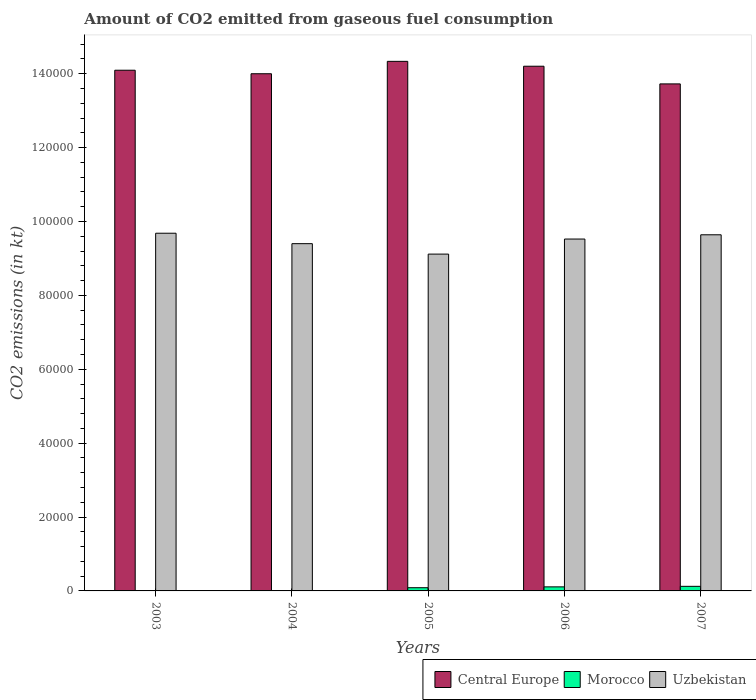Are the number of bars per tick equal to the number of legend labels?
Your response must be concise. Yes. How many bars are there on the 5th tick from the left?
Offer a terse response. 3. How many bars are there on the 5th tick from the right?
Your response must be concise. 3. What is the label of the 5th group of bars from the left?
Your answer should be very brief. 2007. In how many cases, is the number of bars for a given year not equal to the number of legend labels?
Keep it short and to the point. 0. What is the amount of CO2 emitted in Morocco in 2003?
Offer a terse response. 80.67. Across all years, what is the maximum amount of CO2 emitted in Uzbekistan?
Offer a terse response. 9.68e+04. Across all years, what is the minimum amount of CO2 emitted in Uzbekistan?
Provide a short and direct response. 9.12e+04. In which year was the amount of CO2 emitted in Central Europe maximum?
Give a very brief answer. 2005. In which year was the amount of CO2 emitted in Morocco minimum?
Keep it short and to the point. 2003. What is the total amount of CO2 emitted in Morocco in the graph?
Give a very brief answer. 3388.31. What is the difference between the amount of CO2 emitted in Uzbekistan in 2003 and that in 2005?
Keep it short and to the point. 5650.85. What is the difference between the amount of CO2 emitted in Morocco in 2005 and the amount of CO2 emitted in Central Europe in 2003?
Give a very brief answer. -1.40e+05. What is the average amount of CO2 emitted in Uzbekistan per year?
Your answer should be very brief. 9.47e+04. In the year 2004, what is the difference between the amount of CO2 emitted in Morocco and amount of CO2 emitted in Uzbekistan?
Ensure brevity in your answer.  -9.39e+04. In how many years, is the amount of CO2 emitted in Morocco greater than 28000 kt?
Keep it short and to the point. 0. What is the ratio of the amount of CO2 emitted in Uzbekistan in 2005 to that in 2006?
Give a very brief answer. 0.96. Is the amount of CO2 emitted in Central Europe in 2005 less than that in 2007?
Offer a very short reply. No. What is the difference between the highest and the second highest amount of CO2 emitted in Central Europe?
Offer a terse response. 1320.12. What is the difference between the highest and the lowest amount of CO2 emitted in Morocco?
Offer a terse response. 1162.44. Is the sum of the amount of CO2 emitted in Morocco in 2004 and 2006 greater than the maximum amount of CO2 emitted in Central Europe across all years?
Give a very brief answer. No. What does the 1st bar from the left in 2003 represents?
Offer a very short reply. Central Europe. What does the 3rd bar from the right in 2005 represents?
Offer a terse response. Central Europe. How many years are there in the graph?
Ensure brevity in your answer.  5. What is the difference between two consecutive major ticks on the Y-axis?
Ensure brevity in your answer.  2.00e+04. Does the graph contain grids?
Make the answer very short. No. How are the legend labels stacked?
Your answer should be very brief. Horizontal. What is the title of the graph?
Your answer should be compact. Amount of CO2 emitted from gaseous fuel consumption. Does "Germany" appear as one of the legend labels in the graph?
Give a very brief answer. No. What is the label or title of the X-axis?
Your answer should be very brief. Years. What is the label or title of the Y-axis?
Provide a short and direct response. CO2 emissions (in kt). What is the CO2 emissions (in kt) of Central Europe in 2003?
Ensure brevity in your answer.  1.41e+05. What is the CO2 emissions (in kt) in Morocco in 2003?
Your answer should be very brief. 80.67. What is the CO2 emissions (in kt) of Uzbekistan in 2003?
Your answer should be very brief. 9.68e+04. What is the CO2 emissions (in kt) in Central Europe in 2004?
Offer a very short reply. 1.40e+05. What is the CO2 emissions (in kt) of Morocco in 2004?
Offer a terse response. 99.01. What is the CO2 emissions (in kt) of Uzbekistan in 2004?
Provide a succinct answer. 9.40e+04. What is the CO2 emissions (in kt) of Central Europe in 2005?
Your answer should be very brief. 1.43e+05. What is the CO2 emissions (in kt) in Morocco in 2005?
Keep it short and to the point. 869.08. What is the CO2 emissions (in kt) of Uzbekistan in 2005?
Provide a short and direct response. 9.12e+04. What is the CO2 emissions (in kt) in Central Europe in 2006?
Make the answer very short. 1.42e+05. What is the CO2 emissions (in kt) in Morocco in 2006?
Your response must be concise. 1096.43. What is the CO2 emissions (in kt) of Uzbekistan in 2006?
Offer a very short reply. 9.52e+04. What is the CO2 emissions (in kt) of Central Europe in 2007?
Your answer should be very brief. 1.37e+05. What is the CO2 emissions (in kt) of Morocco in 2007?
Give a very brief answer. 1243.11. What is the CO2 emissions (in kt) in Uzbekistan in 2007?
Offer a very short reply. 9.64e+04. Across all years, what is the maximum CO2 emissions (in kt) in Central Europe?
Provide a succinct answer. 1.43e+05. Across all years, what is the maximum CO2 emissions (in kt) of Morocco?
Your response must be concise. 1243.11. Across all years, what is the maximum CO2 emissions (in kt) of Uzbekistan?
Your answer should be compact. 9.68e+04. Across all years, what is the minimum CO2 emissions (in kt) of Central Europe?
Offer a terse response. 1.37e+05. Across all years, what is the minimum CO2 emissions (in kt) of Morocco?
Provide a succinct answer. 80.67. Across all years, what is the minimum CO2 emissions (in kt) in Uzbekistan?
Keep it short and to the point. 9.12e+04. What is the total CO2 emissions (in kt) of Central Europe in the graph?
Keep it short and to the point. 7.03e+05. What is the total CO2 emissions (in kt) in Morocco in the graph?
Make the answer very short. 3388.31. What is the total CO2 emissions (in kt) in Uzbekistan in the graph?
Your response must be concise. 4.74e+05. What is the difference between the CO2 emissions (in kt) in Central Europe in 2003 and that in 2004?
Offer a very short reply. 949.75. What is the difference between the CO2 emissions (in kt) of Morocco in 2003 and that in 2004?
Provide a succinct answer. -18.34. What is the difference between the CO2 emissions (in kt) in Uzbekistan in 2003 and that in 2004?
Make the answer very short. 2823.59. What is the difference between the CO2 emissions (in kt) in Central Europe in 2003 and that in 2005?
Provide a short and direct response. -2401.89. What is the difference between the CO2 emissions (in kt) of Morocco in 2003 and that in 2005?
Offer a terse response. -788.4. What is the difference between the CO2 emissions (in kt) in Uzbekistan in 2003 and that in 2005?
Your answer should be very brief. 5650.85. What is the difference between the CO2 emissions (in kt) of Central Europe in 2003 and that in 2006?
Give a very brief answer. -1081.77. What is the difference between the CO2 emissions (in kt) of Morocco in 2003 and that in 2006?
Provide a short and direct response. -1015.76. What is the difference between the CO2 emissions (in kt) of Uzbekistan in 2003 and that in 2006?
Provide a short and direct response. 1573.14. What is the difference between the CO2 emissions (in kt) in Central Europe in 2003 and that in 2007?
Ensure brevity in your answer.  3700. What is the difference between the CO2 emissions (in kt) of Morocco in 2003 and that in 2007?
Your response must be concise. -1162.44. What is the difference between the CO2 emissions (in kt) in Uzbekistan in 2003 and that in 2007?
Offer a very short reply. 421.7. What is the difference between the CO2 emissions (in kt) in Central Europe in 2004 and that in 2005?
Offer a very short reply. -3351.64. What is the difference between the CO2 emissions (in kt) in Morocco in 2004 and that in 2005?
Ensure brevity in your answer.  -770.07. What is the difference between the CO2 emissions (in kt) in Uzbekistan in 2004 and that in 2005?
Offer a very short reply. 2827.26. What is the difference between the CO2 emissions (in kt) in Central Europe in 2004 and that in 2006?
Offer a terse response. -2031.52. What is the difference between the CO2 emissions (in kt) of Morocco in 2004 and that in 2006?
Your answer should be compact. -997.42. What is the difference between the CO2 emissions (in kt) of Uzbekistan in 2004 and that in 2006?
Give a very brief answer. -1250.45. What is the difference between the CO2 emissions (in kt) of Central Europe in 2004 and that in 2007?
Your response must be concise. 2750.25. What is the difference between the CO2 emissions (in kt) of Morocco in 2004 and that in 2007?
Your response must be concise. -1144.1. What is the difference between the CO2 emissions (in kt) in Uzbekistan in 2004 and that in 2007?
Provide a succinct answer. -2401.89. What is the difference between the CO2 emissions (in kt) of Central Europe in 2005 and that in 2006?
Make the answer very short. 1320.12. What is the difference between the CO2 emissions (in kt) of Morocco in 2005 and that in 2006?
Give a very brief answer. -227.35. What is the difference between the CO2 emissions (in kt) of Uzbekistan in 2005 and that in 2006?
Your answer should be very brief. -4077.7. What is the difference between the CO2 emissions (in kt) of Central Europe in 2005 and that in 2007?
Offer a terse response. 6101.89. What is the difference between the CO2 emissions (in kt) of Morocco in 2005 and that in 2007?
Make the answer very short. -374.03. What is the difference between the CO2 emissions (in kt) in Uzbekistan in 2005 and that in 2007?
Give a very brief answer. -5229.14. What is the difference between the CO2 emissions (in kt) of Central Europe in 2006 and that in 2007?
Offer a very short reply. 4781.77. What is the difference between the CO2 emissions (in kt) in Morocco in 2006 and that in 2007?
Provide a succinct answer. -146.68. What is the difference between the CO2 emissions (in kt) of Uzbekistan in 2006 and that in 2007?
Provide a short and direct response. -1151.44. What is the difference between the CO2 emissions (in kt) of Central Europe in 2003 and the CO2 emissions (in kt) of Morocco in 2004?
Your answer should be very brief. 1.41e+05. What is the difference between the CO2 emissions (in kt) of Central Europe in 2003 and the CO2 emissions (in kt) of Uzbekistan in 2004?
Your response must be concise. 4.69e+04. What is the difference between the CO2 emissions (in kt) of Morocco in 2003 and the CO2 emissions (in kt) of Uzbekistan in 2004?
Provide a short and direct response. -9.39e+04. What is the difference between the CO2 emissions (in kt) in Central Europe in 2003 and the CO2 emissions (in kt) in Morocco in 2005?
Provide a succinct answer. 1.40e+05. What is the difference between the CO2 emissions (in kt) of Central Europe in 2003 and the CO2 emissions (in kt) of Uzbekistan in 2005?
Provide a short and direct response. 4.98e+04. What is the difference between the CO2 emissions (in kt) of Morocco in 2003 and the CO2 emissions (in kt) of Uzbekistan in 2005?
Ensure brevity in your answer.  -9.11e+04. What is the difference between the CO2 emissions (in kt) in Central Europe in 2003 and the CO2 emissions (in kt) in Morocco in 2006?
Your answer should be very brief. 1.40e+05. What is the difference between the CO2 emissions (in kt) in Central Europe in 2003 and the CO2 emissions (in kt) in Uzbekistan in 2006?
Provide a short and direct response. 4.57e+04. What is the difference between the CO2 emissions (in kt) in Morocco in 2003 and the CO2 emissions (in kt) in Uzbekistan in 2006?
Your answer should be compact. -9.52e+04. What is the difference between the CO2 emissions (in kt) in Central Europe in 2003 and the CO2 emissions (in kt) in Morocco in 2007?
Provide a succinct answer. 1.40e+05. What is the difference between the CO2 emissions (in kt) in Central Europe in 2003 and the CO2 emissions (in kt) in Uzbekistan in 2007?
Give a very brief answer. 4.45e+04. What is the difference between the CO2 emissions (in kt) of Morocco in 2003 and the CO2 emissions (in kt) of Uzbekistan in 2007?
Your response must be concise. -9.63e+04. What is the difference between the CO2 emissions (in kt) in Central Europe in 2004 and the CO2 emissions (in kt) in Morocco in 2005?
Your answer should be very brief. 1.39e+05. What is the difference between the CO2 emissions (in kt) in Central Europe in 2004 and the CO2 emissions (in kt) in Uzbekistan in 2005?
Ensure brevity in your answer.  4.88e+04. What is the difference between the CO2 emissions (in kt) in Morocco in 2004 and the CO2 emissions (in kt) in Uzbekistan in 2005?
Your answer should be compact. -9.11e+04. What is the difference between the CO2 emissions (in kt) in Central Europe in 2004 and the CO2 emissions (in kt) in Morocco in 2006?
Make the answer very short. 1.39e+05. What is the difference between the CO2 emissions (in kt) in Central Europe in 2004 and the CO2 emissions (in kt) in Uzbekistan in 2006?
Keep it short and to the point. 4.47e+04. What is the difference between the CO2 emissions (in kt) of Morocco in 2004 and the CO2 emissions (in kt) of Uzbekistan in 2006?
Give a very brief answer. -9.51e+04. What is the difference between the CO2 emissions (in kt) in Central Europe in 2004 and the CO2 emissions (in kt) in Morocco in 2007?
Provide a short and direct response. 1.39e+05. What is the difference between the CO2 emissions (in kt) of Central Europe in 2004 and the CO2 emissions (in kt) of Uzbekistan in 2007?
Offer a very short reply. 4.36e+04. What is the difference between the CO2 emissions (in kt) of Morocco in 2004 and the CO2 emissions (in kt) of Uzbekistan in 2007?
Keep it short and to the point. -9.63e+04. What is the difference between the CO2 emissions (in kt) in Central Europe in 2005 and the CO2 emissions (in kt) in Morocco in 2006?
Offer a terse response. 1.42e+05. What is the difference between the CO2 emissions (in kt) in Central Europe in 2005 and the CO2 emissions (in kt) in Uzbekistan in 2006?
Ensure brevity in your answer.  4.81e+04. What is the difference between the CO2 emissions (in kt) in Morocco in 2005 and the CO2 emissions (in kt) in Uzbekistan in 2006?
Your answer should be compact. -9.44e+04. What is the difference between the CO2 emissions (in kt) of Central Europe in 2005 and the CO2 emissions (in kt) of Morocco in 2007?
Keep it short and to the point. 1.42e+05. What is the difference between the CO2 emissions (in kt) in Central Europe in 2005 and the CO2 emissions (in kt) in Uzbekistan in 2007?
Keep it short and to the point. 4.69e+04. What is the difference between the CO2 emissions (in kt) in Morocco in 2005 and the CO2 emissions (in kt) in Uzbekistan in 2007?
Ensure brevity in your answer.  -9.55e+04. What is the difference between the CO2 emissions (in kt) in Central Europe in 2006 and the CO2 emissions (in kt) in Morocco in 2007?
Your answer should be compact. 1.41e+05. What is the difference between the CO2 emissions (in kt) in Central Europe in 2006 and the CO2 emissions (in kt) in Uzbekistan in 2007?
Your answer should be compact. 4.56e+04. What is the difference between the CO2 emissions (in kt) of Morocco in 2006 and the CO2 emissions (in kt) of Uzbekistan in 2007?
Ensure brevity in your answer.  -9.53e+04. What is the average CO2 emissions (in kt) in Central Europe per year?
Your answer should be very brief. 1.41e+05. What is the average CO2 emissions (in kt) in Morocco per year?
Give a very brief answer. 677.66. What is the average CO2 emissions (in kt) of Uzbekistan per year?
Offer a very short reply. 9.47e+04. In the year 2003, what is the difference between the CO2 emissions (in kt) in Central Europe and CO2 emissions (in kt) in Morocco?
Provide a short and direct response. 1.41e+05. In the year 2003, what is the difference between the CO2 emissions (in kt) in Central Europe and CO2 emissions (in kt) in Uzbekistan?
Offer a terse response. 4.41e+04. In the year 2003, what is the difference between the CO2 emissions (in kt) of Morocco and CO2 emissions (in kt) of Uzbekistan?
Offer a terse response. -9.67e+04. In the year 2004, what is the difference between the CO2 emissions (in kt) in Central Europe and CO2 emissions (in kt) in Morocco?
Offer a very short reply. 1.40e+05. In the year 2004, what is the difference between the CO2 emissions (in kt) in Central Europe and CO2 emissions (in kt) in Uzbekistan?
Give a very brief answer. 4.60e+04. In the year 2004, what is the difference between the CO2 emissions (in kt) of Morocco and CO2 emissions (in kt) of Uzbekistan?
Your answer should be compact. -9.39e+04. In the year 2005, what is the difference between the CO2 emissions (in kt) of Central Europe and CO2 emissions (in kt) of Morocco?
Your answer should be very brief. 1.42e+05. In the year 2005, what is the difference between the CO2 emissions (in kt) of Central Europe and CO2 emissions (in kt) of Uzbekistan?
Make the answer very short. 5.22e+04. In the year 2005, what is the difference between the CO2 emissions (in kt) of Morocco and CO2 emissions (in kt) of Uzbekistan?
Offer a terse response. -9.03e+04. In the year 2006, what is the difference between the CO2 emissions (in kt) in Central Europe and CO2 emissions (in kt) in Morocco?
Offer a very short reply. 1.41e+05. In the year 2006, what is the difference between the CO2 emissions (in kt) of Central Europe and CO2 emissions (in kt) of Uzbekistan?
Ensure brevity in your answer.  4.68e+04. In the year 2006, what is the difference between the CO2 emissions (in kt) in Morocco and CO2 emissions (in kt) in Uzbekistan?
Offer a terse response. -9.41e+04. In the year 2007, what is the difference between the CO2 emissions (in kt) in Central Europe and CO2 emissions (in kt) in Morocco?
Provide a short and direct response. 1.36e+05. In the year 2007, what is the difference between the CO2 emissions (in kt) of Central Europe and CO2 emissions (in kt) of Uzbekistan?
Give a very brief answer. 4.08e+04. In the year 2007, what is the difference between the CO2 emissions (in kt) of Morocco and CO2 emissions (in kt) of Uzbekistan?
Provide a succinct answer. -9.51e+04. What is the ratio of the CO2 emissions (in kt) in Central Europe in 2003 to that in 2004?
Offer a terse response. 1.01. What is the ratio of the CO2 emissions (in kt) in Morocco in 2003 to that in 2004?
Offer a very short reply. 0.81. What is the ratio of the CO2 emissions (in kt) of Central Europe in 2003 to that in 2005?
Offer a terse response. 0.98. What is the ratio of the CO2 emissions (in kt) of Morocco in 2003 to that in 2005?
Offer a very short reply. 0.09. What is the ratio of the CO2 emissions (in kt) in Uzbekistan in 2003 to that in 2005?
Make the answer very short. 1.06. What is the ratio of the CO2 emissions (in kt) of Morocco in 2003 to that in 2006?
Make the answer very short. 0.07. What is the ratio of the CO2 emissions (in kt) in Uzbekistan in 2003 to that in 2006?
Your answer should be compact. 1.02. What is the ratio of the CO2 emissions (in kt) of Central Europe in 2003 to that in 2007?
Offer a terse response. 1.03. What is the ratio of the CO2 emissions (in kt) of Morocco in 2003 to that in 2007?
Ensure brevity in your answer.  0.06. What is the ratio of the CO2 emissions (in kt) of Uzbekistan in 2003 to that in 2007?
Offer a very short reply. 1. What is the ratio of the CO2 emissions (in kt) in Central Europe in 2004 to that in 2005?
Offer a very short reply. 0.98. What is the ratio of the CO2 emissions (in kt) in Morocco in 2004 to that in 2005?
Offer a terse response. 0.11. What is the ratio of the CO2 emissions (in kt) in Uzbekistan in 2004 to that in 2005?
Offer a very short reply. 1.03. What is the ratio of the CO2 emissions (in kt) in Central Europe in 2004 to that in 2006?
Your answer should be very brief. 0.99. What is the ratio of the CO2 emissions (in kt) of Morocco in 2004 to that in 2006?
Keep it short and to the point. 0.09. What is the ratio of the CO2 emissions (in kt) of Uzbekistan in 2004 to that in 2006?
Give a very brief answer. 0.99. What is the ratio of the CO2 emissions (in kt) in Morocco in 2004 to that in 2007?
Provide a short and direct response. 0.08. What is the ratio of the CO2 emissions (in kt) in Uzbekistan in 2004 to that in 2007?
Give a very brief answer. 0.98. What is the ratio of the CO2 emissions (in kt) in Central Europe in 2005 to that in 2006?
Your response must be concise. 1.01. What is the ratio of the CO2 emissions (in kt) in Morocco in 2005 to that in 2006?
Provide a succinct answer. 0.79. What is the ratio of the CO2 emissions (in kt) in Uzbekistan in 2005 to that in 2006?
Provide a short and direct response. 0.96. What is the ratio of the CO2 emissions (in kt) of Central Europe in 2005 to that in 2007?
Make the answer very short. 1.04. What is the ratio of the CO2 emissions (in kt) of Morocco in 2005 to that in 2007?
Ensure brevity in your answer.  0.7. What is the ratio of the CO2 emissions (in kt) of Uzbekistan in 2005 to that in 2007?
Your answer should be compact. 0.95. What is the ratio of the CO2 emissions (in kt) of Central Europe in 2006 to that in 2007?
Keep it short and to the point. 1.03. What is the ratio of the CO2 emissions (in kt) in Morocco in 2006 to that in 2007?
Your answer should be very brief. 0.88. What is the ratio of the CO2 emissions (in kt) of Uzbekistan in 2006 to that in 2007?
Make the answer very short. 0.99. What is the difference between the highest and the second highest CO2 emissions (in kt) in Central Europe?
Make the answer very short. 1320.12. What is the difference between the highest and the second highest CO2 emissions (in kt) of Morocco?
Provide a succinct answer. 146.68. What is the difference between the highest and the second highest CO2 emissions (in kt) of Uzbekistan?
Keep it short and to the point. 421.7. What is the difference between the highest and the lowest CO2 emissions (in kt) of Central Europe?
Make the answer very short. 6101.89. What is the difference between the highest and the lowest CO2 emissions (in kt) in Morocco?
Keep it short and to the point. 1162.44. What is the difference between the highest and the lowest CO2 emissions (in kt) of Uzbekistan?
Make the answer very short. 5650.85. 